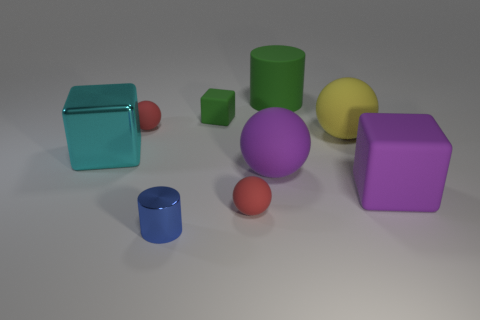There is a blue metallic thing that is the same size as the green rubber cube; what is its shape?
Make the answer very short. Cylinder. Do the red ball that is in front of the big yellow thing and the rubber cube in front of the small green thing have the same size?
Provide a succinct answer. No. What is the color of the cylinder that is the same material as the purple ball?
Make the answer very short. Green. Are the block that is behind the big cyan block and the cylinder in front of the big green matte cylinder made of the same material?
Ensure brevity in your answer.  No. Are there any other rubber objects of the same size as the cyan thing?
Make the answer very short. Yes. What size is the rubber block in front of the small rubber ball to the left of the tiny blue cylinder?
Offer a terse response. Large. What number of small cubes have the same color as the matte cylinder?
Your answer should be very brief. 1. There is a red matte thing that is behind the red thing right of the small blue thing; what shape is it?
Offer a very short reply. Sphere. What number of things are the same material as the big yellow ball?
Your answer should be compact. 6. There is a cylinder that is right of the green cube; what is it made of?
Your response must be concise. Rubber. 